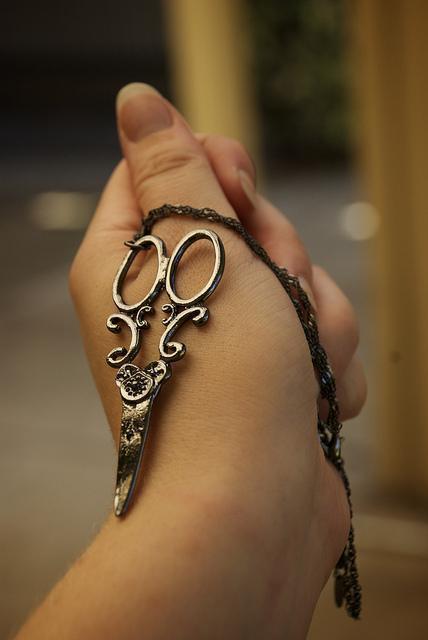How many giraffes are there?
Give a very brief answer. 0. 